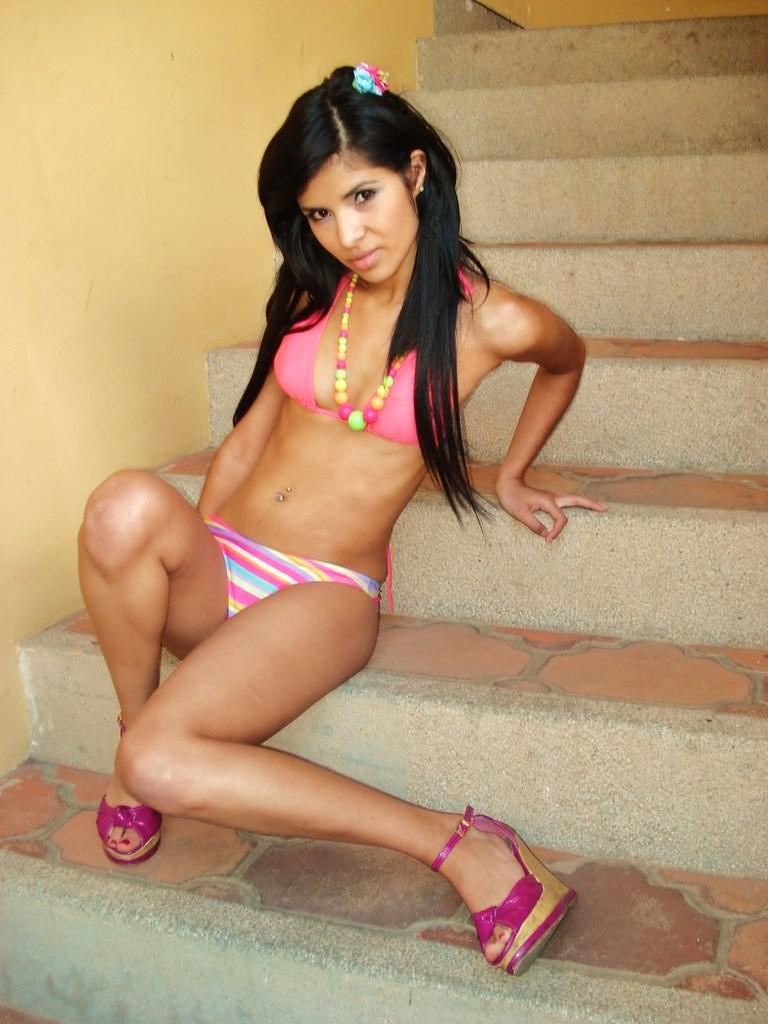What is the main subject of the image? The main subject of the image is a girl. What is the girl doing in the image? The girl is sitting on the steps. What is the girl wearing in the image? The girl is wearing a bikini. What type of feather can be seen in the girl's hair in the image? There is no feather present in the girl's hair in the image. What does the girl's uncle say to her in the image? There is no uncle present in the image, and therefore no conversation can be observed. 